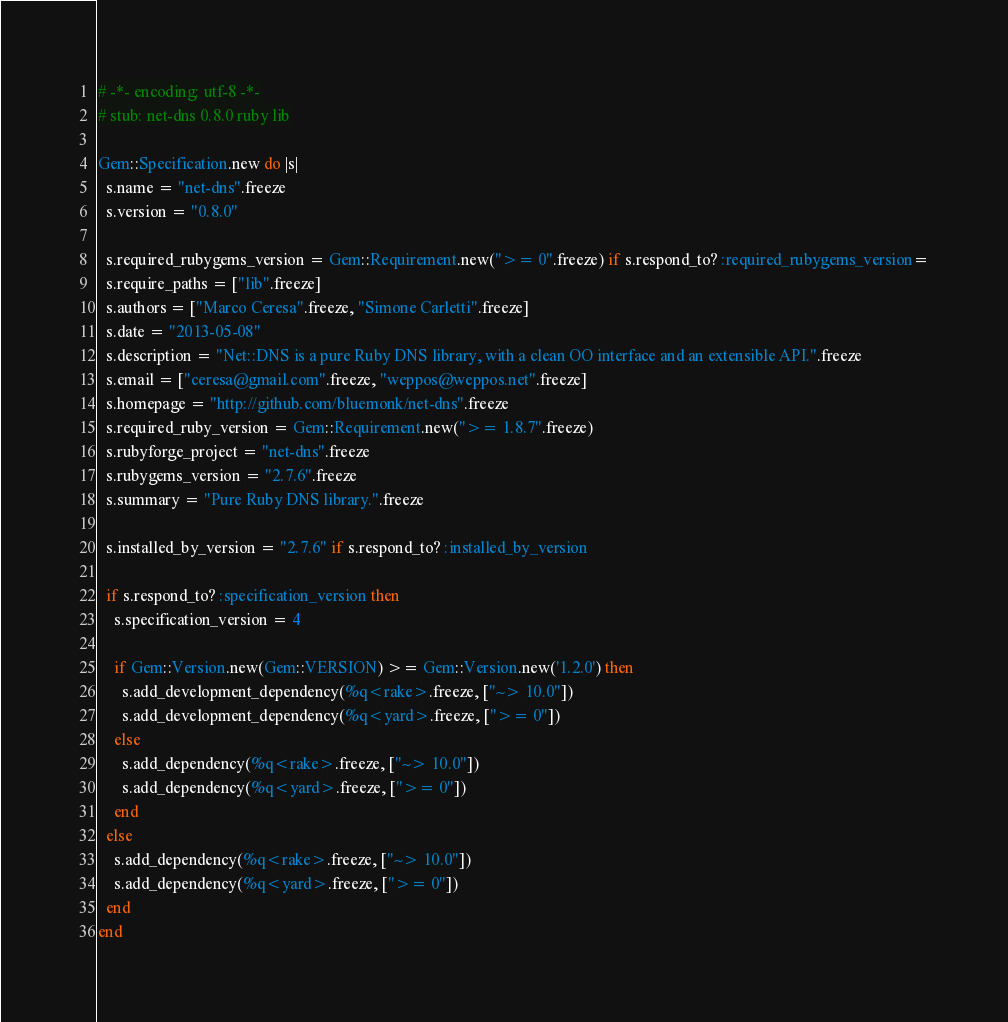<code> <loc_0><loc_0><loc_500><loc_500><_Ruby_># -*- encoding: utf-8 -*-
# stub: net-dns 0.8.0 ruby lib

Gem::Specification.new do |s|
  s.name = "net-dns".freeze
  s.version = "0.8.0"

  s.required_rubygems_version = Gem::Requirement.new(">= 0".freeze) if s.respond_to? :required_rubygems_version=
  s.require_paths = ["lib".freeze]
  s.authors = ["Marco Ceresa".freeze, "Simone Carletti".freeze]
  s.date = "2013-05-08"
  s.description = "Net::DNS is a pure Ruby DNS library, with a clean OO interface and an extensible API.".freeze
  s.email = ["ceresa@gmail.com".freeze, "weppos@weppos.net".freeze]
  s.homepage = "http://github.com/bluemonk/net-dns".freeze
  s.required_ruby_version = Gem::Requirement.new(">= 1.8.7".freeze)
  s.rubyforge_project = "net-dns".freeze
  s.rubygems_version = "2.7.6".freeze
  s.summary = "Pure Ruby DNS library.".freeze

  s.installed_by_version = "2.7.6" if s.respond_to? :installed_by_version

  if s.respond_to? :specification_version then
    s.specification_version = 4

    if Gem::Version.new(Gem::VERSION) >= Gem::Version.new('1.2.0') then
      s.add_development_dependency(%q<rake>.freeze, ["~> 10.0"])
      s.add_development_dependency(%q<yard>.freeze, [">= 0"])
    else
      s.add_dependency(%q<rake>.freeze, ["~> 10.0"])
      s.add_dependency(%q<yard>.freeze, [">= 0"])
    end
  else
    s.add_dependency(%q<rake>.freeze, ["~> 10.0"])
    s.add_dependency(%q<yard>.freeze, [">= 0"])
  end
end
</code> 